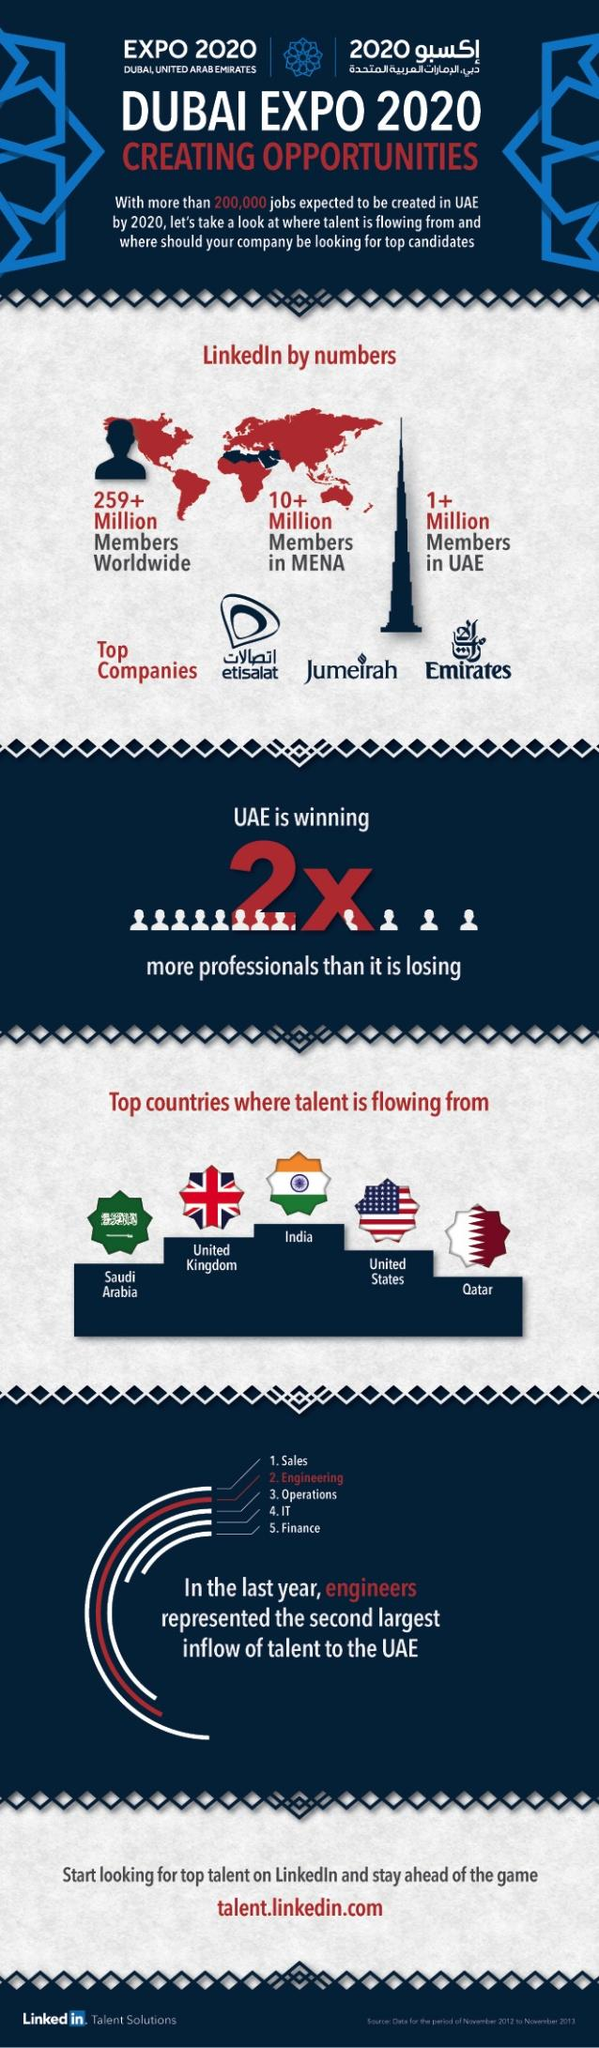Outline some significant characteristics in this image. There are approximately 259 million LinkedIn members worldwide. After India, the United Kingdom has the most talented individuals being flown into the United Arab Emirates. For every single talent lost, the UAE is winning two talents in total. Etisalat is the leading telecommunications company in the United Arab Emirates. The third largest inflow of talents is in the category of operations. 